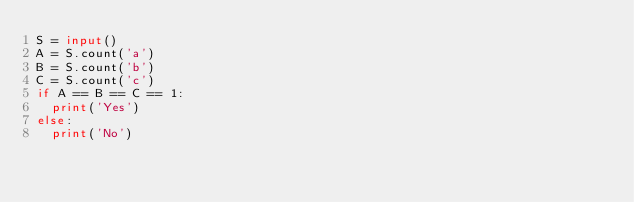<code> <loc_0><loc_0><loc_500><loc_500><_Python_>S = input()
A = S.count('a')
B = S.count('b')
C = S.count('c')
if A == B == C == 1:
  print('Yes')
else:
  print('No')</code> 